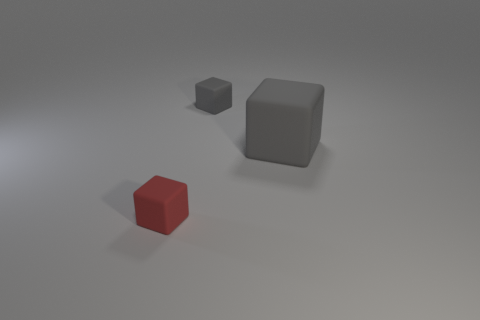How many other objects are there of the same material as the tiny gray block?
Make the answer very short. 2. Do the tiny red block and the small object that is behind the red matte object have the same material?
Ensure brevity in your answer.  Yes. Is the number of small blocks to the right of the big gray thing less than the number of rubber things that are in front of the tiny red cube?
Offer a terse response. No. The object that is to the right of the small gray block is what color?
Provide a short and direct response. Gray. How many other objects are there of the same color as the big matte object?
Your answer should be very brief. 1. Is the number of small red objects the same as the number of tiny purple shiny cylinders?
Provide a succinct answer. No. How many gray rubber objects are in front of the red thing?
Make the answer very short. 0. Are there any gray rubber cubes that have the same size as the red rubber thing?
Provide a short and direct response. Yes. What is the color of the block that is to the right of the gray cube that is behind the large thing?
Provide a short and direct response. Gray. What number of tiny matte blocks are in front of the large cube and right of the small red cube?
Provide a short and direct response. 0. 